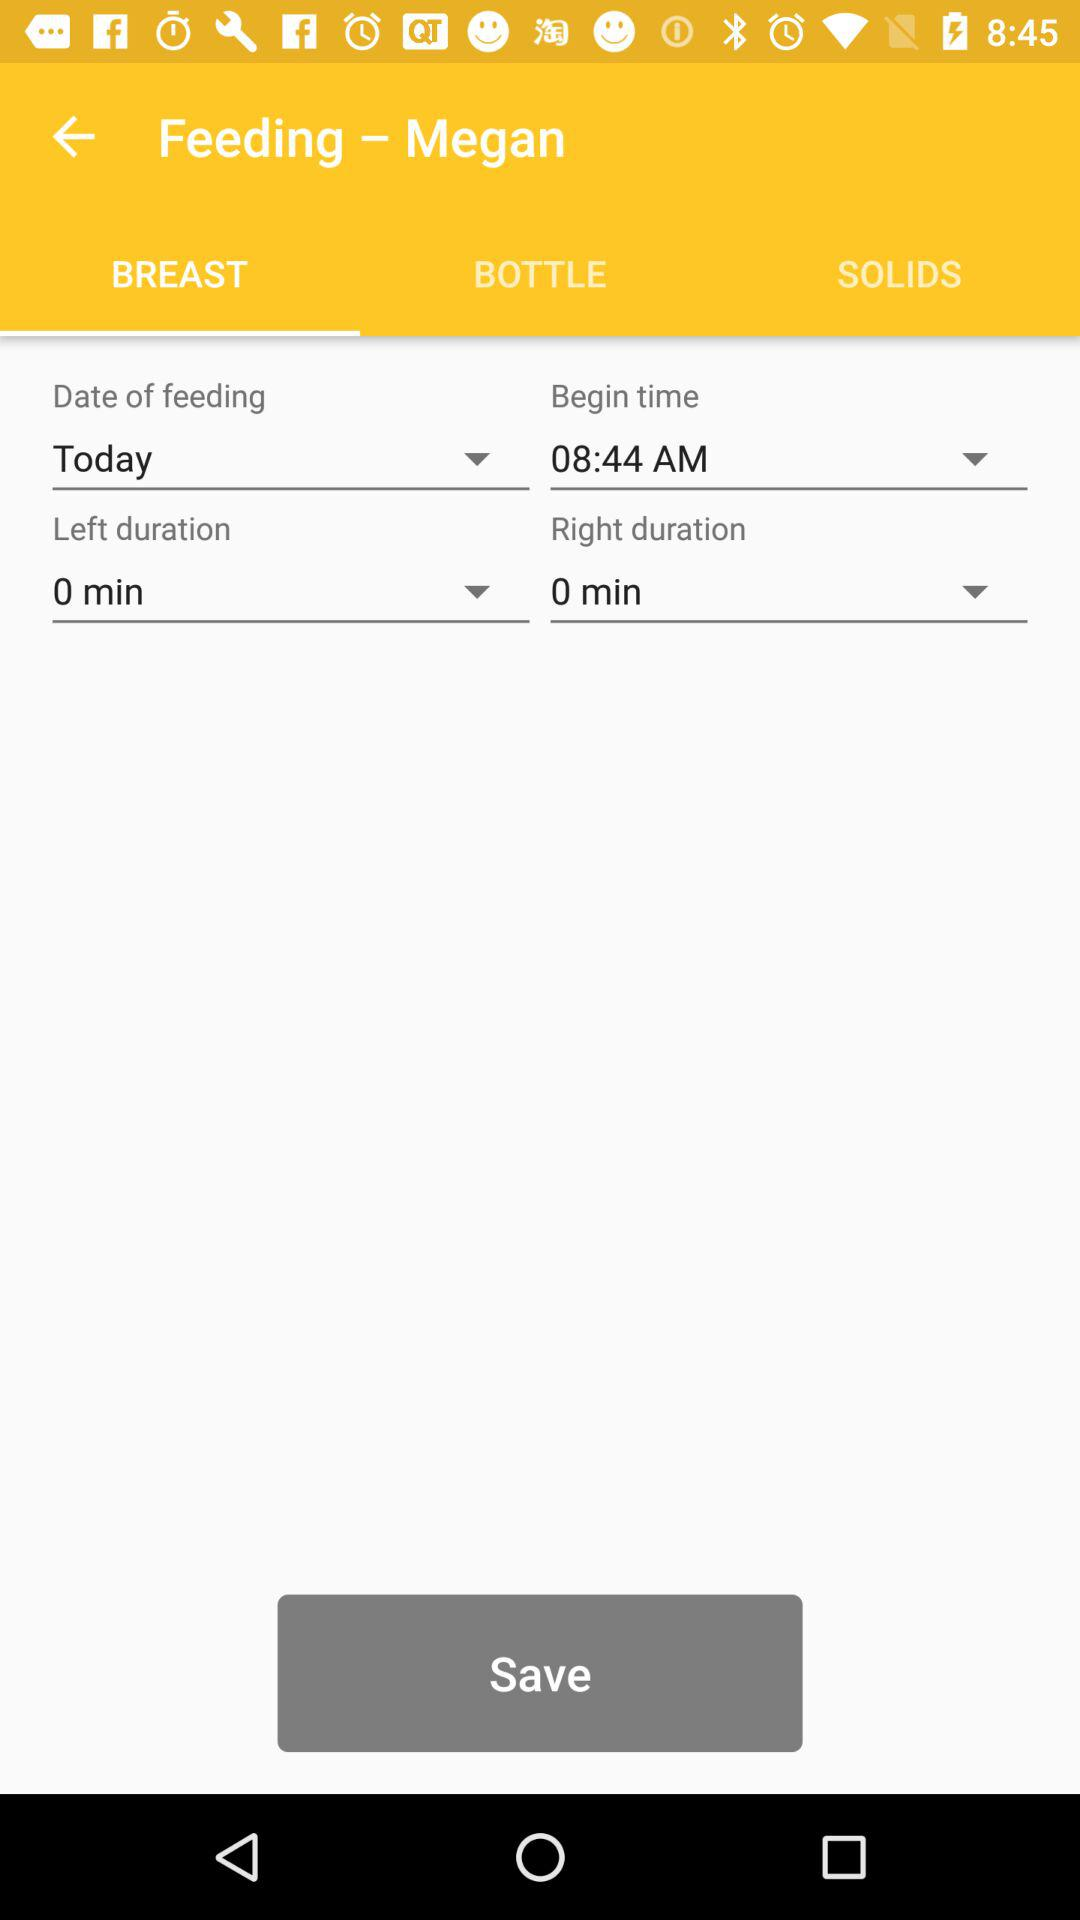What is the selected option for "Date of feeding"? The selected option is "Today". 